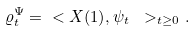<formula> <loc_0><loc_0><loc_500><loc_500>\varrho _ { t } ^ { \Psi } = \ < X ( 1 ) , \psi _ { t } \ > _ { t \geq 0 } .</formula> 